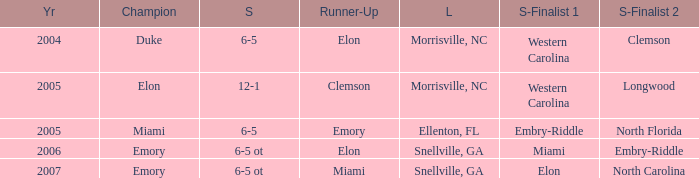When Embry-Riddle made it to the first semi finalist slot, list all the runners up. Emory. 